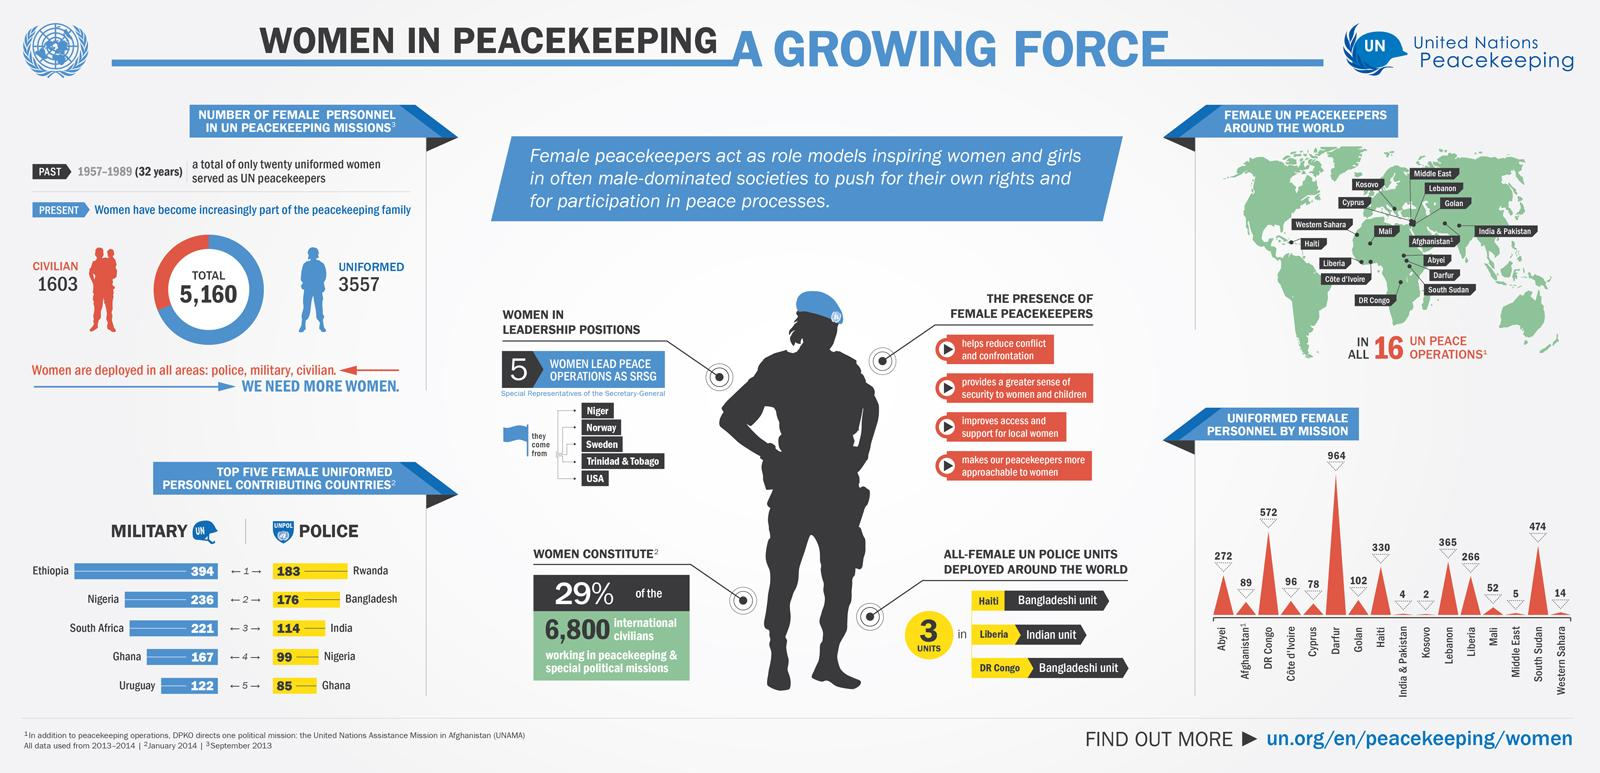Identify some key points in this picture. Ethiopia is the country that contributes the most women as UN peacekeeping forces. In peacekeeping and special political missions, only 29% of international civilians are women, despite efforts to increase their participation. The Darfur mission had the highest number of female personnel among all the missions. The mission that had the least number of female personnel was Kosovo. According to recent data, approximately 31% of civilian women are part of peacekeeping families. 